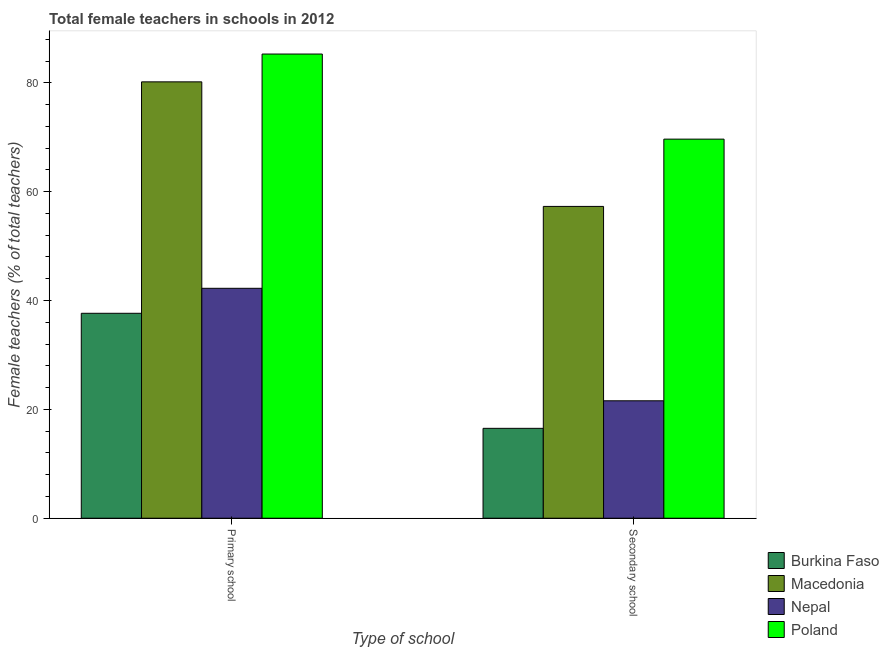Are the number of bars per tick equal to the number of legend labels?
Provide a short and direct response. Yes. What is the label of the 2nd group of bars from the left?
Offer a very short reply. Secondary school. What is the percentage of female teachers in primary schools in Nepal?
Your answer should be very brief. 42.24. Across all countries, what is the maximum percentage of female teachers in primary schools?
Provide a short and direct response. 85.28. Across all countries, what is the minimum percentage of female teachers in primary schools?
Your answer should be compact. 37.65. In which country was the percentage of female teachers in primary schools maximum?
Provide a succinct answer. Poland. In which country was the percentage of female teachers in secondary schools minimum?
Make the answer very short. Burkina Faso. What is the total percentage of female teachers in secondary schools in the graph?
Provide a succinct answer. 165.03. What is the difference between the percentage of female teachers in primary schools in Burkina Faso and that in Nepal?
Make the answer very short. -4.59. What is the difference between the percentage of female teachers in secondary schools in Nepal and the percentage of female teachers in primary schools in Poland?
Your response must be concise. -63.71. What is the average percentage of female teachers in primary schools per country?
Provide a short and direct response. 61.34. What is the difference between the percentage of female teachers in secondary schools and percentage of female teachers in primary schools in Burkina Faso?
Your response must be concise. -21.14. In how many countries, is the percentage of female teachers in primary schools greater than 8 %?
Your answer should be compact. 4. What is the ratio of the percentage of female teachers in secondary schools in Poland to that in Nepal?
Offer a terse response. 3.23. Is the percentage of female teachers in primary schools in Nepal less than that in Macedonia?
Your answer should be very brief. Yes. What does the 1st bar from the left in Secondary school represents?
Your answer should be very brief. Burkina Faso. What does the 2nd bar from the right in Primary school represents?
Your response must be concise. Nepal. How many countries are there in the graph?
Keep it short and to the point. 4. What is the difference between two consecutive major ticks on the Y-axis?
Provide a succinct answer. 20. Are the values on the major ticks of Y-axis written in scientific E-notation?
Your answer should be very brief. No. Does the graph contain any zero values?
Your answer should be very brief. No. Where does the legend appear in the graph?
Your answer should be very brief. Bottom right. What is the title of the graph?
Offer a terse response. Total female teachers in schools in 2012. What is the label or title of the X-axis?
Keep it short and to the point. Type of school. What is the label or title of the Y-axis?
Provide a short and direct response. Female teachers (% of total teachers). What is the Female teachers (% of total teachers) of Burkina Faso in Primary school?
Your answer should be very brief. 37.65. What is the Female teachers (% of total teachers) of Macedonia in Primary school?
Offer a very short reply. 80.17. What is the Female teachers (% of total teachers) in Nepal in Primary school?
Keep it short and to the point. 42.24. What is the Female teachers (% of total teachers) in Poland in Primary school?
Make the answer very short. 85.28. What is the Female teachers (% of total teachers) in Burkina Faso in Secondary school?
Your answer should be compact. 16.52. What is the Female teachers (% of total teachers) in Macedonia in Secondary school?
Your answer should be very brief. 57.29. What is the Female teachers (% of total teachers) of Nepal in Secondary school?
Give a very brief answer. 21.58. What is the Female teachers (% of total teachers) of Poland in Secondary school?
Provide a succinct answer. 69.65. Across all Type of school, what is the maximum Female teachers (% of total teachers) in Burkina Faso?
Give a very brief answer. 37.65. Across all Type of school, what is the maximum Female teachers (% of total teachers) of Macedonia?
Provide a succinct answer. 80.17. Across all Type of school, what is the maximum Female teachers (% of total teachers) in Nepal?
Offer a very short reply. 42.24. Across all Type of school, what is the maximum Female teachers (% of total teachers) of Poland?
Your answer should be very brief. 85.28. Across all Type of school, what is the minimum Female teachers (% of total teachers) of Burkina Faso?
Keep it short and to the point. 16.52. Across all Type of school, what is the minimum Female teachers (% of total teachers) in Macedonia?
Offer a very short reply. 57.29. Across all Type of school, what is the minimum Female teachers (% of total teachers) in Nepal?
Provide a succinct answer. 21.58. Across all Type of school, what is the minimum Female teachers (% of total teachers) of Poland?
Your answer should be very brief. 69.65. What is the total Female teachers (% of total teachers) in Burkina Faso in the graph?
Your answer should be very brief. 54.17. What is the total Female teachers (% of total teachers) in Macedonia in the graph?
Offer a terse response. 137.46. What is the total Female teachers (% of total teachers) in Nepal in the graph?
Offer a very short reply. 63.82. What is the total Female teachers (% of total teachers) of Poland in the graph?
Make the answer very short. 154.93. What is the difference between the Female teachers (% of total teachers) of Burkina Faso in Primary school and that in Secondary school?
Make the answer very short. 21.14. What is the difference between the Female teachers (% of total teachers) in Macedonia in Primary school and that in Secondary school?
Make the answer very short. 22.88. What is the difference between the Female teachers (% of total teachers) in Nepal in Primary school and that in Secondary school?
Keep it short and to the point. 20.67. What is the difference between the Female teachers (% of total teachers) in Poland in Primary school and that in Secondary school?
Make the answer very short. 15.63. What is the difference between the Female teachers (% of total teachers) in Burkina Faso in Primary school and the Female teachers (% of total teachers) in Macedonia in Secondary school?
Offer a very short reply. -19.64. What is the difference between the Female teachers (% of total teachers) of Burkina Faso in Primary school and the Female teachers (% of total teachers) of Nepal in Secondary school?
Your answer should be compact. 16.08. What is the difference between the Female teachers (% of total teachers) of Burkina Faso in Primary school and the Female teachers (% of total teachers) of Poland in Secondary school?
Your answer should be very brief. -32. What is the difference between the Female teachers (% of total teachers) of Macedonia in Primary school and the Female teachers (% of total teachers) of Nepal in Secondary school?
Give a very brief answer. 58.6. What is the difference between the Female teachers (% of total teachers) of Macedonia in Primary school and the Female teachers (% of total teachers) of Poland in Secondary school?
Keep it short and to the point. 10.52. What is the difference between the Female teachers (% of total teachers) in Nepal in Primary school and the Female teachers (% of total teachers) in Poland in Secondary school?
Ensure brevity in your answer.  -27.41. What is the average Female teachers (% of total teachers) of Burkina Faso per Type of school?
Provide a short and direct response. 27.08. What is the average Female teachers (% of total teachers) in Macedonia per Type of school?
Offer a terse response. 68.73. What is the average Female teachers (% of total teachers) of Nepal per Type of school?
Offer a terse response. 31.91. What is the average Female teachers (% of total teachers) in Poland per Type of school?
Offer a terse response. 77.47. What is the difference between the Female teachers (% of total teachers) in Burkina Faso and Female teachers (% of total teachers) in Macedonia in Primary school?
Ensure brevity in your answer.  -42.52. What is the difference between the Female teachers (% of total teachers) of Burkina Faso and Female teachers (% of total teachers) of Nepal in Primary school?
Give a very brief answer. -4.59. What is the difference between the Female teachers (% of total teachers) of Burkina Faso and Female teachers (% of total teachers) of Poland in Primary school?
Your answer should be very brief. -47.63. What is the difference between the Female teachers (% of total teachers) of Macedonia and Female teachers (% of total teachers) of Nepal in Primary school?
Offer a very short reply. 37.93. What is the difference between the Female teachers (% of total teachers) of Macedonia and Female teachers (% of total teachers) of Poland in Primary school?
Offer a very short reply. -5.11. What is the difference between the Female teachers (% of total teachers) of Nepal and Female teachers (% of total teachers) of Poland in Primary school?
Offer a terse response. -43.04. What is the difference between the Female teachers (% of total teachers) in Burkina Faso and Female teachers (% of total teachers) in Macedonia in Secondary school?
Offer a terse response. -40.77. What is the difference between the Female teachers (% of total teachers) in Burkina Faso and Female teachers (% of total teachers) in Nepal in Secondary school?
Ensure brevity in your answer.  -5.06. What is the difference between the Female teachers (% of total teachers) of Burkina Faso and Female teachers (% of total teachers) of Poland in Secondary school?
Offer a terse response. -53.13. What is the difference between the Female teachers (% of total teachers) in Macedonia and Female teachers (% of total teachers) in Nepal in Secondary school?
Your answer should be very brief. 35.71. What is the difference between the Female teachers (% of total teachers) of Macedonia and Female teachers (% of total teachers) of Poland in Secondary school?
Provide a short and direct response. -12.36. What is the difference between the Female teachers (% of total teachers) of Nepal and Female teachers (% of total teachers) of Poland in Secondary school?
Make the answer very short. -48.07. What is the ratio of the Female teachers (% of total teachers) in Burkina Faso in Primary school to that in Secondary school?
Make the answer very short. 2.28. What is the ratio of the Female teachers (% of total teachers) of Macedonia in Primary school to that in Secondary school?
Offer a very short reply. 1.4. What is the ratio of the Female teachers (% of total teachers) of Nepal in Primary school to that in Secondary school?
Offer a very short reply. 1.96. What is the ratio of the Female teachers (% of total teachers) in Poland in Primary school to that in Secondary school?
Keep it short and to the point. 1.22. What is the difference between the highest and the second highest Female teachers (% of total teachers) in Burkina Faso?
Provide a succinct answer. 21.14. What is the difference between the highest and the second highest Female teachers (% of total teachers) in Macedonia?
Offer a very short reply. 22.88. What is the difference between the highest and the second highest Female teachers (% of total teachers) of Nepal?
Provide a short and direct response. 20.67. What is the difference between the highest and the second highest Female teachers (% of total teachers) in Poland?
Provide a short and direct response. 15.63. What is the difference between the highest and the lowest Female teachers (% of total teachers) of Burkina Faso?
Offer a very short reply. 21.14. What is the difference between the highest and the lowest Female teachers (% of total teachers) of Macedonia?
Your answer should be very brief. 22.88. What is the difference between the highest and the lowest Female teachers (% of total teachers) of Nepal?
Ensure brevity in your answer.  20.67. What is the difference between the highest and the lowest Female teachers (% of total teachers) in Poland?
Offer a very short reply. 15.63. 